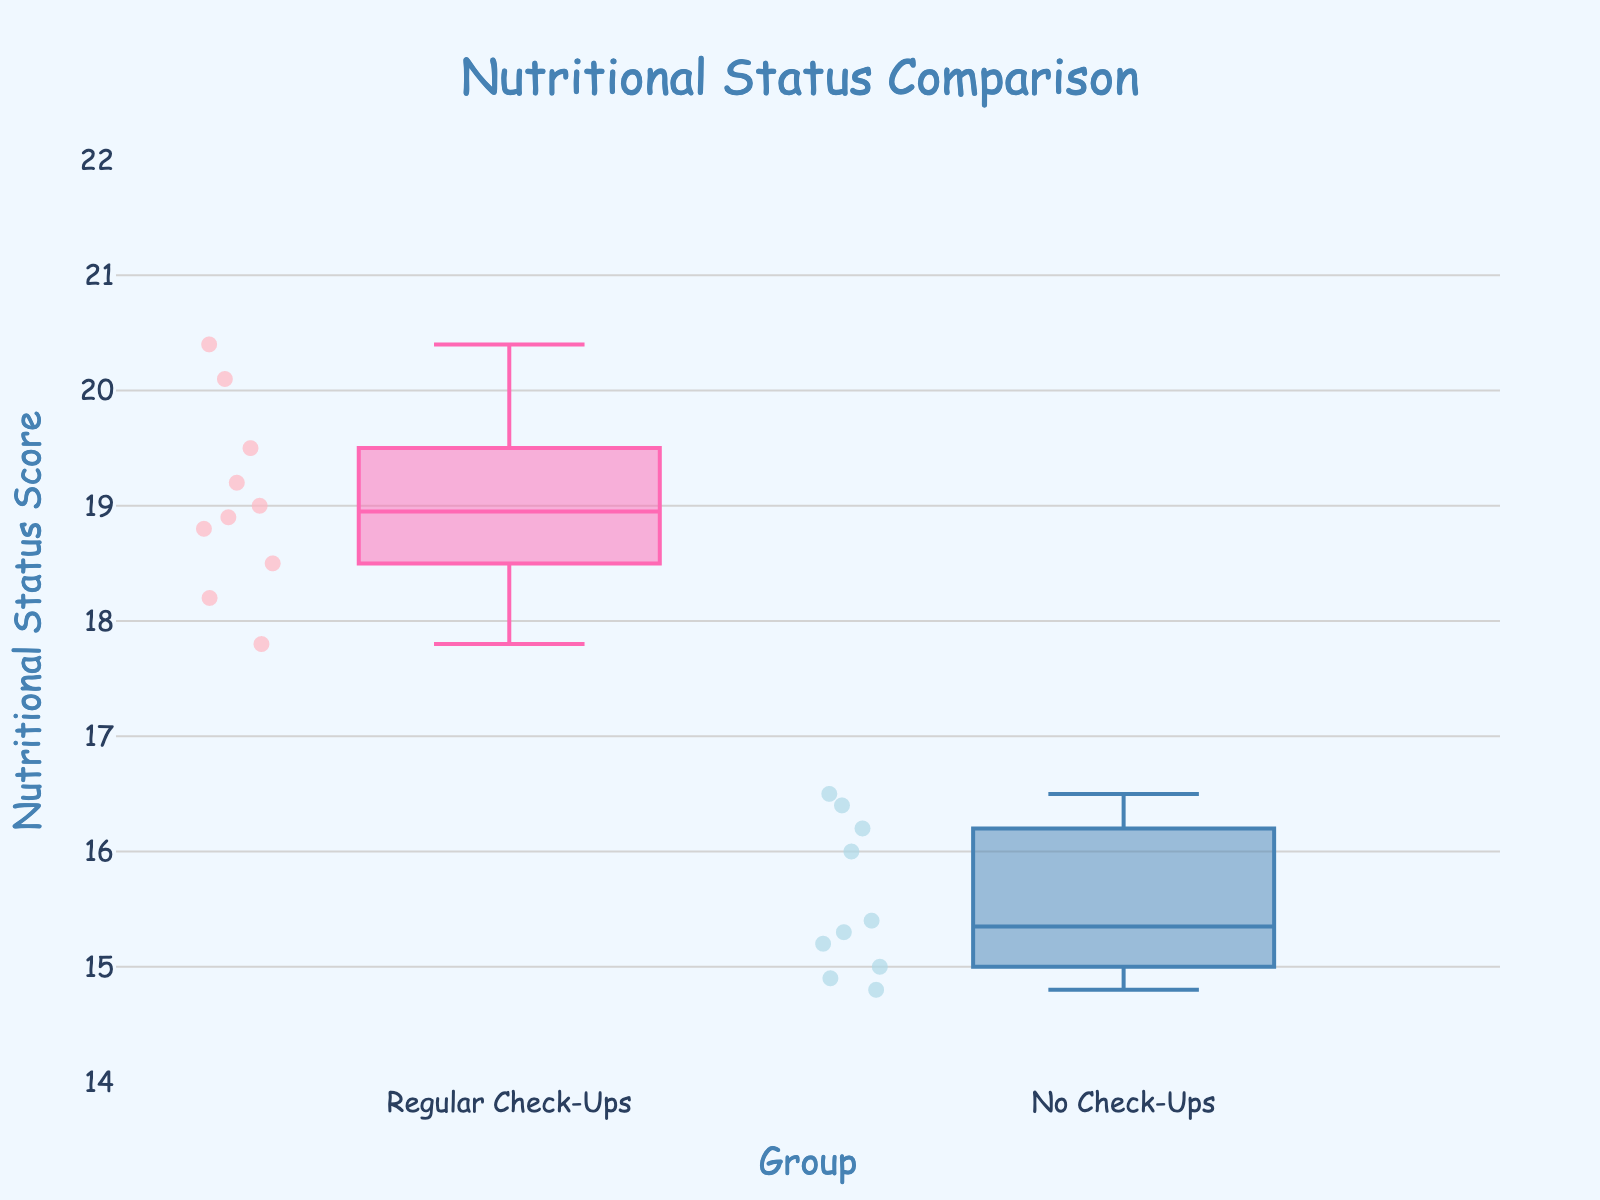What is the title of the figure? The title of the figure is usually displayed prominently at the top. In this case, it reads "Nutritional Status Comparison".
Answer: Nutritional Status Comparison What is shown on the y-axis? The label on the y-axis indicates what is being measured. Here, it reads "Nutritional Status Score".
Answer: Nutritional Status Score What are the two groups being compared? By examining the names on the x-axis and the box plot labels, we can observe the two groups are "Regular Check-Ups" and "No Check-Ups".
Answer: Regular Check-Ups and No Check-Ups Which group has a higher median nutritional status score? Observing the midline of each box plot, which represents the median, we see that the "Regular Check-Ups" group has a higher median score.
Answer: Regular Check-Ups What is the range of nutritional status scores for the group with regular check-ups? The range of a box plot is determined by looking at the minimum and maximum whiskers. For the "Regular Check-Ups" group, the minimum is around 17.8 and the maximum is around 20.4.
Answer: 17.8 to 20.4 How many children are in the "No Check-Ups" group? Each data point is represented by a small marker. Counting the markers in the "No Check-Ups" group gives us 10.
Answer: 10 What is the difference in median scores between the two groups? To find the difference, we look at the median lines inside each box plot. The median for "Regular Check-Ups" is around 19.2, and for "No Check-Ups" it is around 15.4, so the difference is 19.2 - 15.4.
Answer: 3.8 Which group shows more variability in nutritional status scores? Variability can be assessed by the interquartile range (IQR), shown as the height of each box. The "Regular Check-Ups" group has a shorter box than the "No Check-Ups" group, indicating less variability in comparison.
Answer: No Check-Ups Are there any outliers in either group? Outliers are usually marked by individual points outside the whiskers. There are no such points in either box plot in this figure.
Answer: No What is the interquartile range (IQR) for children in the "No Check-Ups" group? IQR is the range between the first quartile (bottom of the box) and the third quartile (top of the box). For "No Check-Ups", it ranges from about 15.0 to 16.2.
Answer: 1.2 